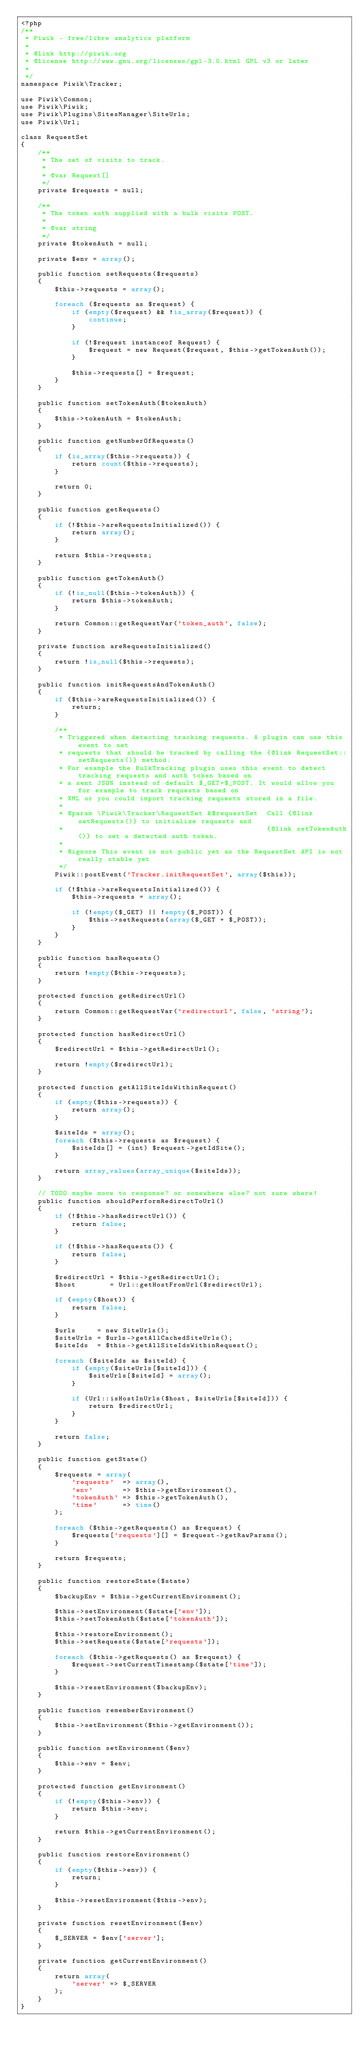<code> <loc_0><loc_0><loc_500><loc_500><_PHP_><?php
/**
 * Piwik - free/libre analytics platform
 *
 * @link http://piwik.org
 * @license http://www.gnu.org/licenses/gpl-3.0.html GPL v3 or later
 *
 */
namespace Piwik\Tracker;

use Piwik\Common;
use Piwik\Piwik;
use Piwik\Plugins\SitesManager\SiteUrls;
use Piwik\Url;

class RequestSet
{
    /**
     * The set of visits to track.
     *
     * @var Request[]
     */
    private $requests = null;

    /**
     * The token auth supplied with a bulk visits POST.
     *
     * @var string
     */
    private $tokenAuth = null;

    private $env = array();

    public function setRequests($requests)
    {
        $this->requests = array();

        foreach ($requests as $request) {
            if (empty($request) && !is_array($request)) {
                continue;
            }

            if (!$request instanceof Request) {
                $request = new Request($request, $this->getTokenAuth());
            }

            $this->requests[] = $request;
        }
    }

    public function setTokenAuth($tokenAuth)
    {
        $this->tokenAuth = $tokenAuth;
    }

    public function getNumberOfRequests()
    {
        if (is_array($this->requests)) {
            return count($this->requests);
        }

        return 0;
    }

    public function getRequests()
    {
        if (!$this->areRequestsInitialized()) {
            return array();
        }

        return $this->requests;
    }

    public function getTokenAuth()
    {
        if (!is_null($this->tokenAuth)) {
            return $this->tokenAuth;
        }

        return Common::getRequestVar('token_auth', false);
    }

    private function areRequestsInitialized()
    {
        return !is_null($this->requests);
    }

    public function initRequestsAndTokenAuth()
    {
        if ($this->areRequestsInitialized()) {
            return;
        }

        /**
         * Triggered when detecting tracking requests. A plugin can use this event to set
         * requests that should be tracked by calling the {@link RequestSet::setRequests()} method.
         * For example the BulkTracking plugin uses this event to detect tracking requests and auth token based on
         * a sent JSON instead of default $_GET+$_POST. It would allow you for example to track requests based on
         * XML or you could import tracking requests stored in a file.
         *
         * @param \Piwik\Tracker\RequestSet &$requestSet  Call {@link setRequests()} to initialize requests and
         *                                                {@link setTokenAuth()} to set a detected auth token.
         *
         * @ignore This event is not public yet as the RequestSet API is not really stable yet
         */
        Piwik::postEvent('Tracker.initRequestSet', array($this));

        if (!$this->areRequestsInitialized()) {
            $this->requests = array();

            if (!empty($_GET) || !empty($_POST)) {
                $this->setRequests(array($_GET + $_POST));
            }
        }
    }

    public function hasRequests()
    {
        return !empty($this->requests);
    }

    protected function getRedirectUrl()
    {
        return Common::getRequestVar('redirecturl', false, 'string');
    }

    protected function hasRedirectUrl()
    {
        $redirectUrl = $this->getRedirectUrl();

        return !empty($redirectUrl);
    }

    protected function getAllSiteIdsWithinRequest()
    {
        if (empty($this->requests)) {
            return array();
        }

        $siteIds = array();
        foreach ($this->requests as $request) {
            $siteIds[] = (int) $request->getIdSite();
        }

        return array_values(array_unique($siteIds));
    }

    // TODO maybe move to response? or somewhere else? not sure where!
    public function shouldPerformRedirectToUrl()
    {
        if (!$this->hasRedirectUrl()) {
            return false;
        }

        if (!$this->hasRequests()) {
            return false;
        }

        $redirectUrl = $this->getRedirectUrl();
        $host        = Url::getHostFromUrl($redirectUrl);

        if (empty($host)) {
            return false;
        }

        $urls     = new SiteUrls();
        $siteUrls = $urls->getAllCachedSiteUrls();
        $siteIds  = $this->getAllSiteIdsWithinRequest();

        foreach ($siteIds as $siteId) {
            if (empty($siteUrls[$siteId])) {
                $siteUrls[$siteId] = array();
            }

            if (Url::isHostInUrls($host, $siteUrls[$siteId])) {
                return $redirectUrl;
            }
        }

        return false;
    }

    public function getState()
    {
        $requests = array(
            'requests'  => array(),
            'env'       => $this->getEnvironment(),
            'tokenAuth' => $this->getTokenAuth(),
            'time'      => time()
        );

        foreach ($this->getRequests() as $request) {
            $requests['requests'][] = $request->getRawParams();
        }

        return $requests;
    }

    public function restoreState($state)
    {
        $backupEnv = $this->getCurrentEnvironment();

        $this->setEnvironment($state['env']);
        $this->setTokenAuth($state['tokenAuth']);

        $this->restoreEnvironment();
        $this->setRequests($state['requests']);

        foreach ($this->getRequests() as $request) {
            $request->setCurrentTimestamp($state['time']);
        }

        $this->resetEnvironment($backupEnv);
    }

    public function rememberEnvironment()
    {
        $this->setEnvironment($this->getEnvironment());
    }

    public function setEnvironment($env)
    {
        $this->env = $env;
    }

    protected function getEnvironment()
    {
        if (!empty($this->env)) {
            return $this->env;
        }

        return $this->getCurrentEnvironment();
    }

    public function restoreEnvironment()
    {
        if (empty($this->env)) {
            return;
        }

        $this->resetEnvironment($this->env);
    }

    private function resetEnvironment($env)
    {
        $_SERVER = $env['server'];
    }

    private function getCurrentEnvironment()
    {
        return array(
            'server' => $_SERVER
        );
    }
}
</code> 